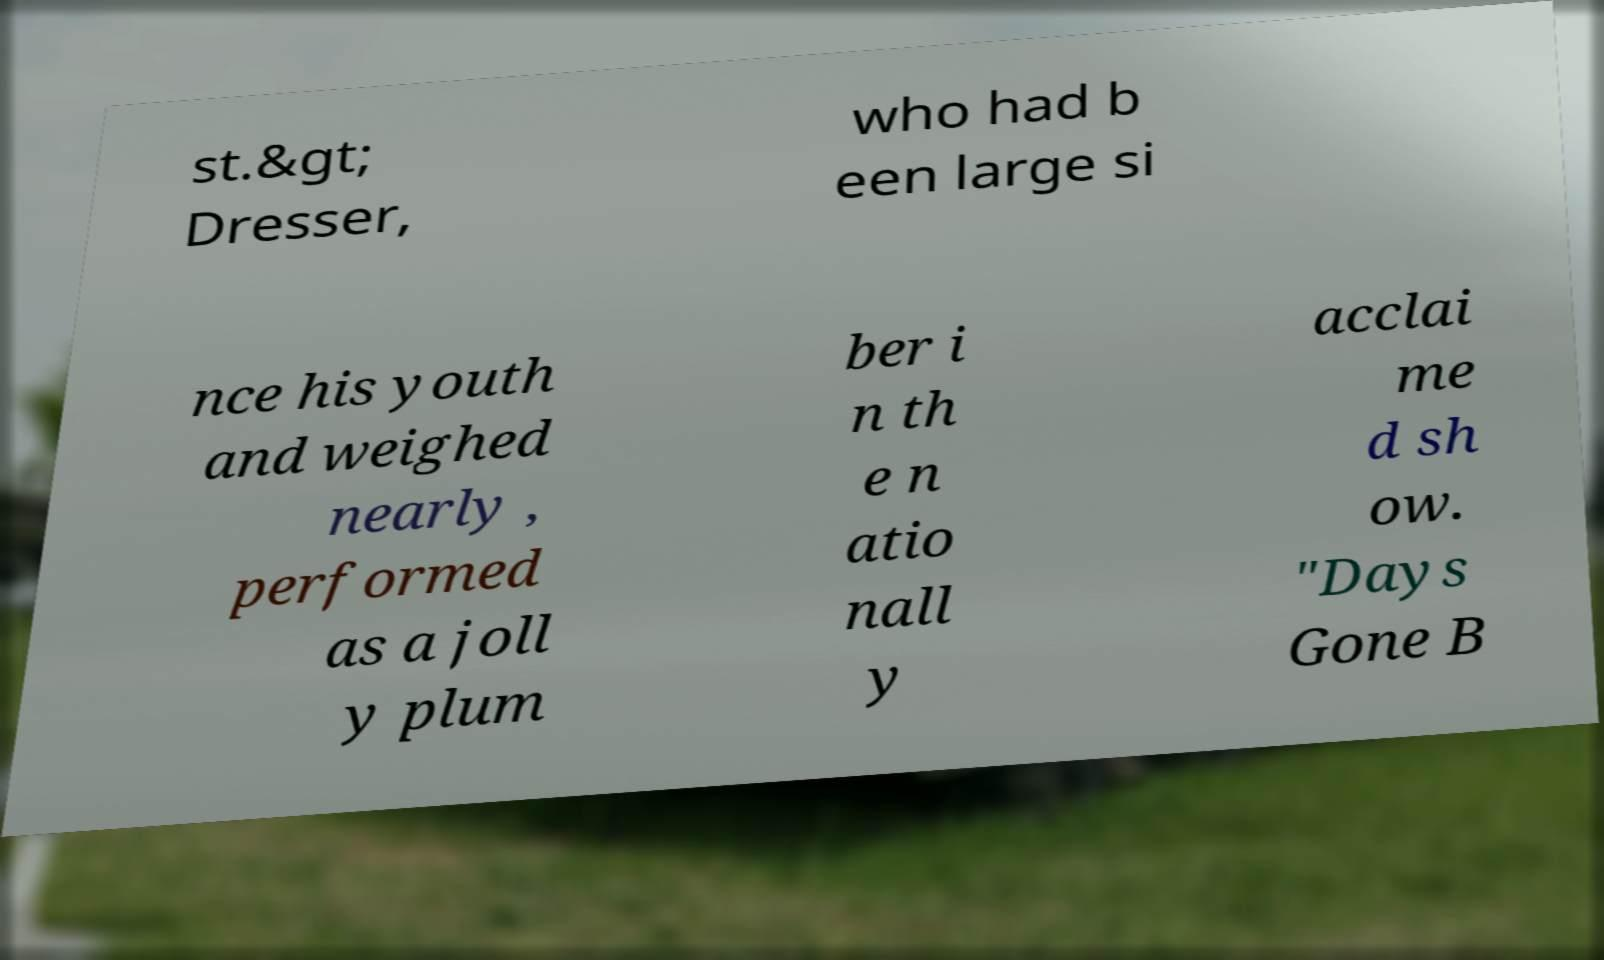Can you read and provide the text displayed in the image?This photo seems to have some interesting text. Can you extract and type it out for me? st.&gt; Dresser, who had b een large si nce his youth and weighed nearly , performed as a joll y plum ber i n th e n atio nall y acclai me d sh ow. "Days Gone B 